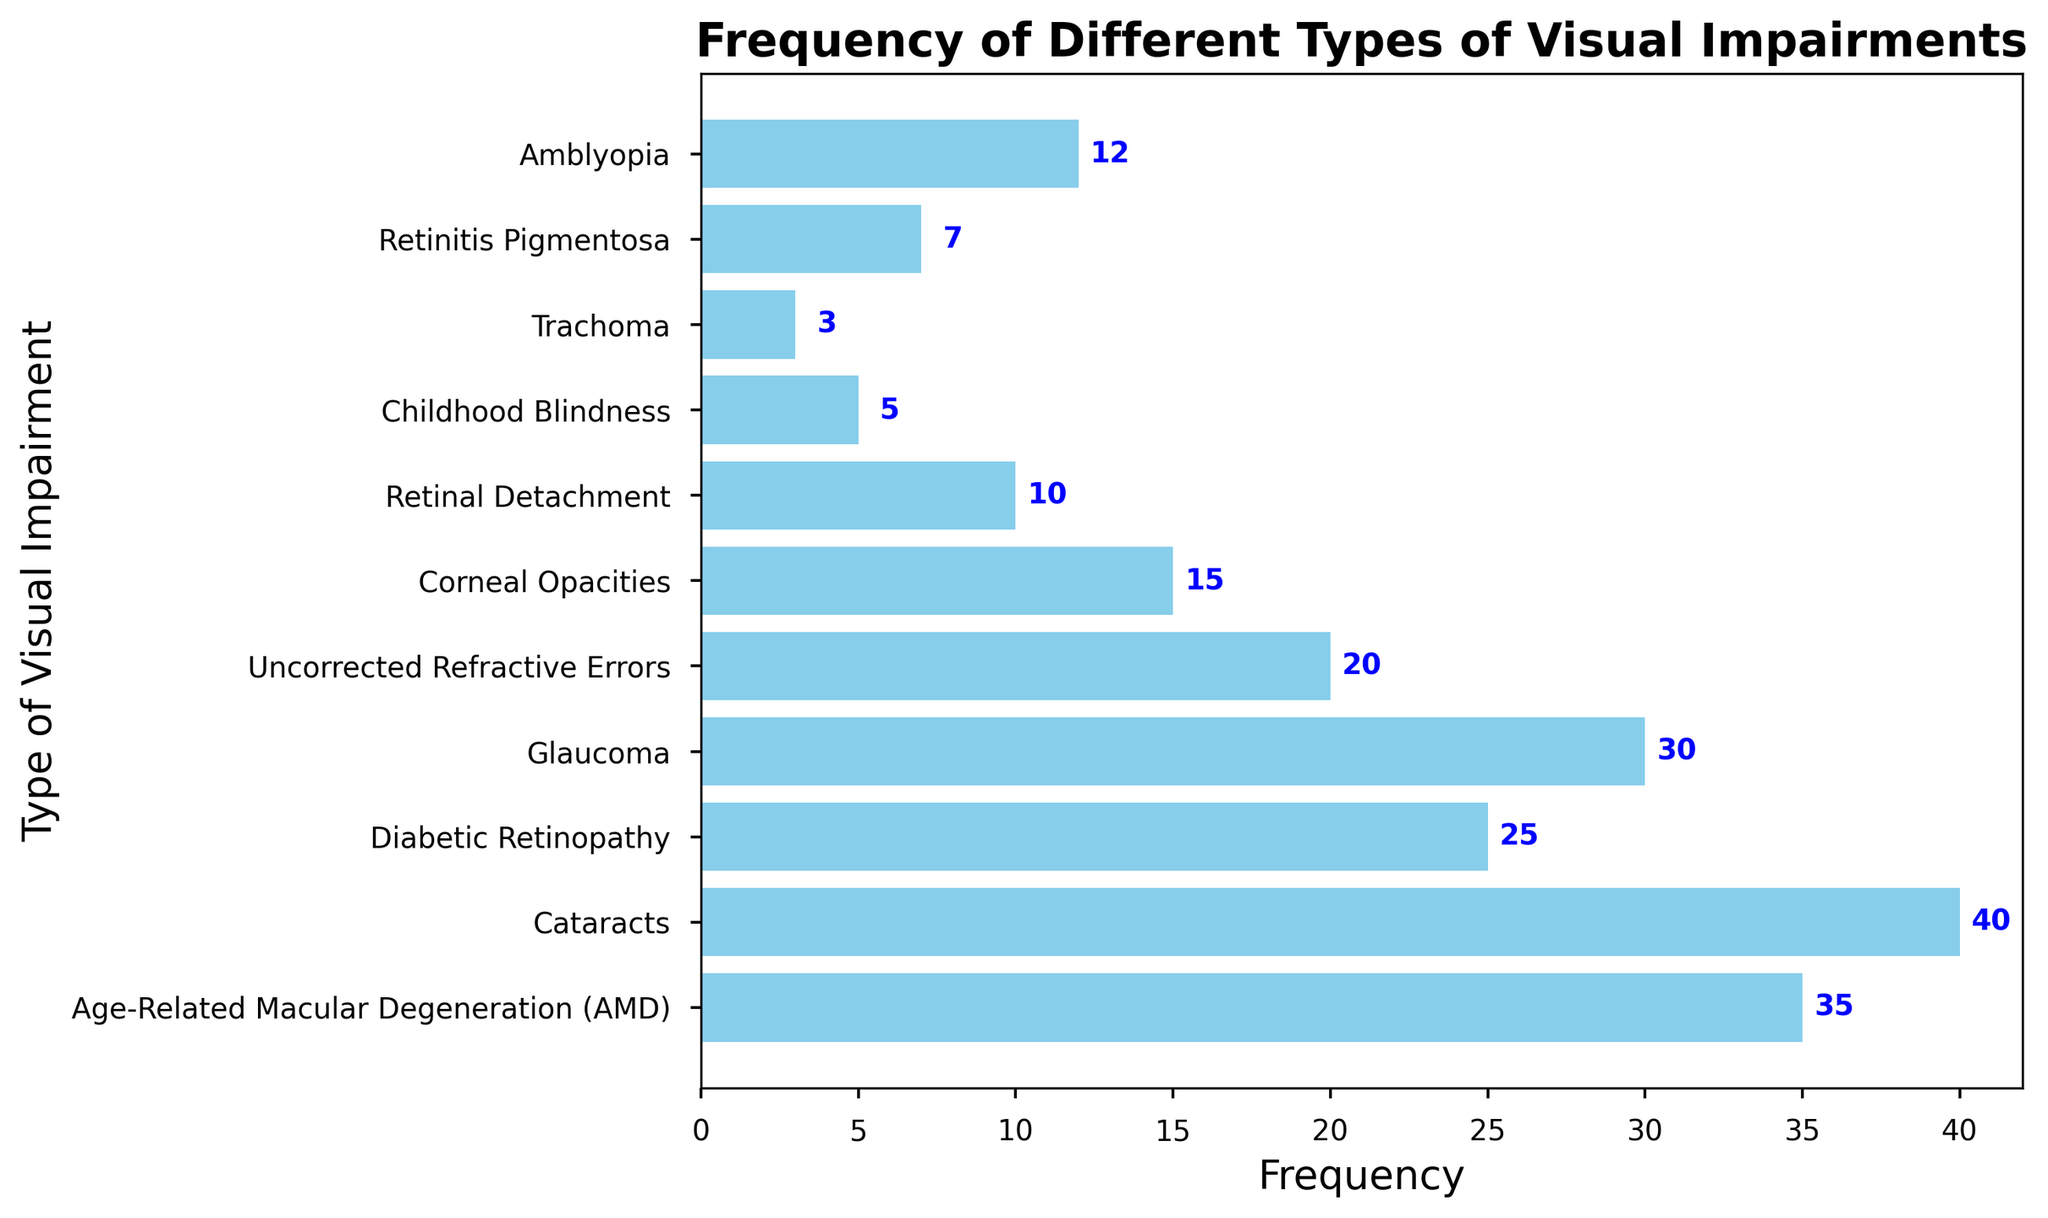What's the most frequent type of visual impairment? Check the bar with the highest frequency. Cataracts has the tallest bar with a frequency of 40.
Answer: Cataracts Which type of visual impairment has the lowest frequency? Look for the shortest bar on the plot. Trachoma has the shortest bar with a frequency of 3.
Answer: Trachoma Are there more patients with Diabetic Retinopathy or Retinitis Pigmentosa? Compare the lengths of the bars for Diabetic Retinopathy and Retinitis Pigmentosa. Diabetic Retinopathy has a frequency of 25 while Retinitis Pigmentosa has a frequency of 7.
Answer: Diabetic Retinopathy How many patients have either Amblyopia or Childhood Blindness? Add the frequencies of Amblyopia and Childhood Blindness. Amblyopia: 12, Childhood Blindness: 5. Total is 12 + 5 = 17.
Answer: 17 What is the total number of patients with Uncorrected Refractive Errors and Corneal Opacities? Sum the frequencies of Uncorrected Refractive Errors and Corneal Opacities. Uncorrected Refractive Errors: 20, Corneal Opacities: 15. Total is 20 + 15 = 35.
Answer: 35 Which is greater: the number of patients with Age-Related Macular Degeneration or the total number of patients with Retinal Detachment and Trachoma? Compare the frequency of Age-Related Macular Degeneration to the sum of the frequencies of Retinal Detachment and Trachoma. Age-Related Macular Degeneration: 35, Retinal Detachment: 10, Trachoma: 3. Sum is 10 + 3 = 13. 35 is greater than 13.
Answer: Age-Related Macular Degeneration What is the average frequency of Cataracts, Glaucoma, and Diabetic Retinopathy? Calculate the average of the frequencies for Cataracts, Glaucoma, and Diabetic Retinopathy. Frequencies are 40, 30, and 25 respectively. Sum is 40 + 30 + 25 = 95. Average is 95 / 3 ≈ 31.67.
Answer: 31.67 Which visual impairment category is represented by the blue bar furthest to the right? Identify the bar with the longest length towards the right end of the plot. This is Cataracts with a frequency of 40.
Answer: Cataracts How many more patients suffer from Cataracts than from Retinal Detachment? Subtract the frequency of Retinal Detachment from that of Cataracts. Cataracts: 40, Retinal Detachment: 10. Difference is 40 - 10 = 30.
Answer: 30 